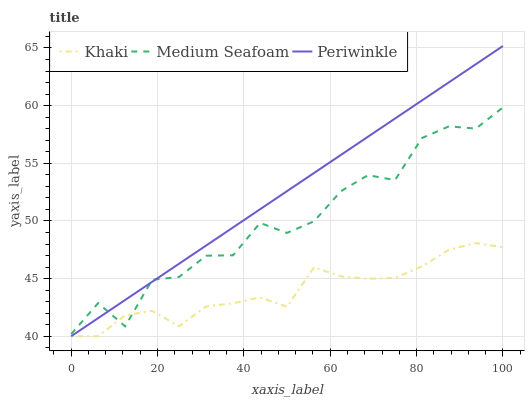Does Khaki have the minimum area under the curve?
Answer yes or no. Yes. Does Periwinkle have the maximum area under the curve?
Answer yes or no. Yes. Does Medium Seafoam have the minimum area under the curve?
Answer yes or no. No. Does Medium Seafoam have the maximum area under the curve?
Answer yes or no. No. Is Periwinkle the smoothest?
Answer yes or no. Yes. Is Medium Seafoam the roughest?
Answer yes or no. Yes. Is Medium Seafoam the smoothest?
Answer yes or no. No. Is Periwinkle the roughest?
Answer yes or no. No. Does Medium Seafoam have the lowest value?
Answer yes or no. No. Does Periwinkle have the highest value?
Answer yes or no. Yes. Does Medium Seafoam have the highest value?
Answer yes or no. No. Does Khaki intersect Periwinkle?
Answer yes or no. Yes. Is Khaki less than Periwinkle?
Answer yes or no. No. Is Khaki greater than Periwinkle?
Answer yes or no. No. 